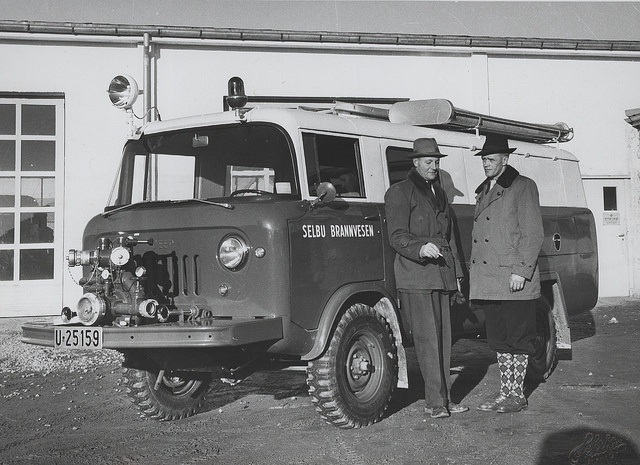Describe the objects in this image and their specific colors. I can see truck in darkgray, gray, black, and lightgray tones, people in darkgray, gray, black, and lightgray tones, people in darkgray, gray, black, and lightgray tones, tie in gray, darkgray, and black tones, and tie in darkgray, gray, black, and lightgray tones in this image. 